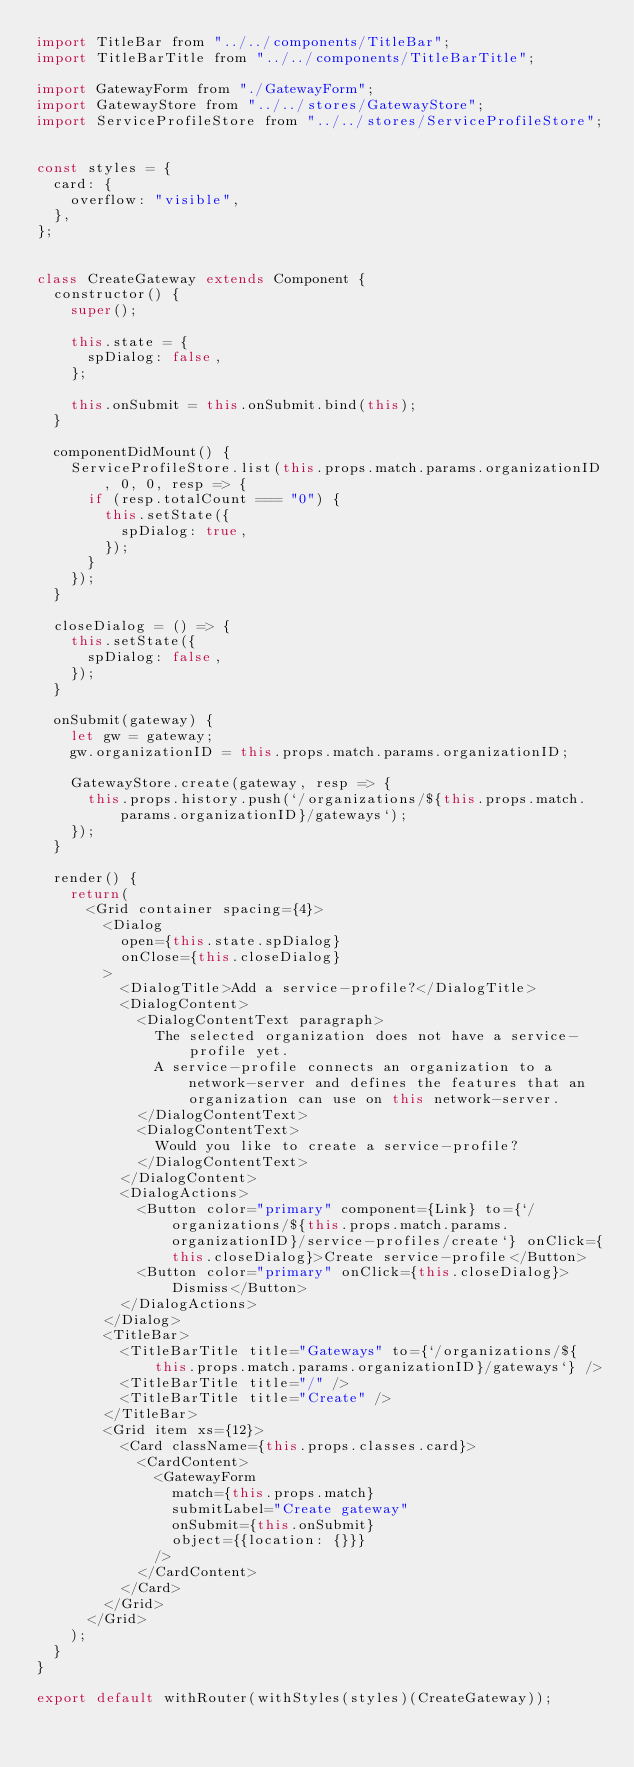<code> <loc_0><loc_0><loc_500><loc_500><_JavaScript_>import TitleBar from "../../components/TitleBar";
import TitleBarTitle from "../../components/TitleBarTitle";

import GatewayForm from "./GatewayForm";
import GatewayStore from "../../stores/GatewayStore";
import ServiceProfileStore from "../../stores/ServiceProfileStore";


const styles = {
  card: {
    overflow: "visible",
  },
};


class CreateGateway extends Component {
  constructor() {
    super();

    this.state = {
      spDialog: false,
    };

    this.onSubmit = this.onSubmit.bind(this);
  }

  componentDidMount() {
    ServiceProfileStore.list(this.props.match.params.organizationID, 0, 0, resp => {
      if (resp.totalCount === "0") {
        this.setState({
          spDialog: true,
        });
      }
    });
  }

  closeDialog = () => {
    this.setState({
      spDialog: false,
    });
  }

  onSubmit(gateway) {
    let gw = gateway;
    gw.organizationID = this.props.match.params.organizationID;

    GatewayStore.create(gateway, resp => {
      this.props.history.push(`/organizations/${this.props.match.params.organizationID}/gateways`);
    });
  }

  render() {
    return(
      <Grid container spacing={4}>
        <Dialog
          open={this.state.spDialog}
          onClose={this.closeDialog}
        >
          <DialogTitle>Add a service-profile?</DialogTitle>
          <DialogContent>
            <DialogContentText paragraph>
              The selected organization does not have a service-profile yet.
              A service-profile connects an organization to a network-server and defines the features that an organization can use on this network-server.
            </DialogContentText>
            <DialogContentText>
              Would you like to create a service-profile?
            </DialogContentText>
          </DialogContent>
          <DialogActions>
            <Button color="primary" component={Link} to={`/organizations/${this.props.match.params.organizationID}/service-profiles/create`} onClick={this.closeDialog}>Create service-profile</Button>
            <Button color="primary" onClick={this.closeDialog}>Dismiss</Button>
          </DialogActions>
        </Dialog>
        <TitleBar>
          <TitleBarTitle title="Gateways" to={`/organizations/${this.props.match.params.organizationID}/gateways`} />
          <TitleBarTitle title="/" />
          <TitleBarTitle title="Create" />
        </TitleBar>
        <Grid item xs={12}>
          <Card className={this.props.classes.card}>
            <CardContent>
              <GatewayForm
                match={this.props.match}
                submitLabel="Create gateway"
                onSubmit={this.onSubmit}
                object={{location: {}}}
              />
            </CardContent>
          </Card>
        </Grid>
      </Grid>
    );
  }
}

export default withRouter(withStyles(styles)(CreateGateway));
</code> 